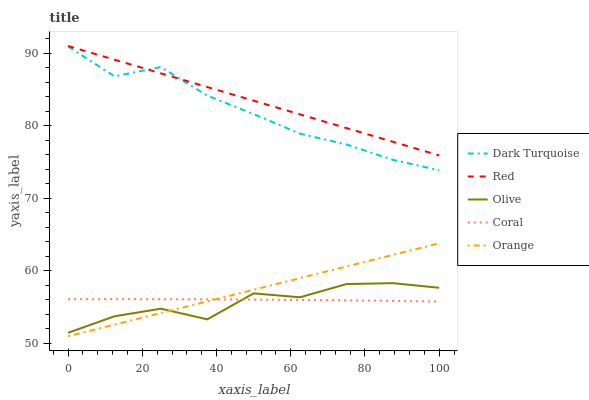Does Olive have the minimum area under the curve?
Answer yes or no. Yes. Does Red have the maximum area under the curve?
Answer yes or no. Yes. Does Dark Turquoise have the minimum area under the curve?
Answer yes or no. No. Does Dark Turquoise have the maximum area under the curve?
Answer yes or no. No. Is Orange the smoothest?
Answer yes or no. Yes. Is Olive the roughest?
Answer yes or no. Yes. Is Dark Turquoise the smoothest?
Answer yes or no. No. Is Dark Turquoise the roughest?
Answer yes or no. No. Does Orange have the lowest value?
Answer yes or no. Yes. Does Dark Turquoise have the lowest value?
Answer yes or no. No. Does Red have the highest value?
Answer yes or no. Yes. Does Dark Turquoise have the highest value?
Answer yes or no. No. Is Orange less than Dark Turquoise?
Answer yes or no. Yes. Is Dark Turquoise greater than Olive?
Answer yes or no. Yes. Does Dark Turquoise intersect Red?
Answer yes or no. Yes. Is Dark Turquoise less than Red?
Answer yes or no. No. Is Dark Turquoise greater than Red?
Answer yes or no. No. Does Orange intersect Dark Turquoise?
Answer yes or no. No. 